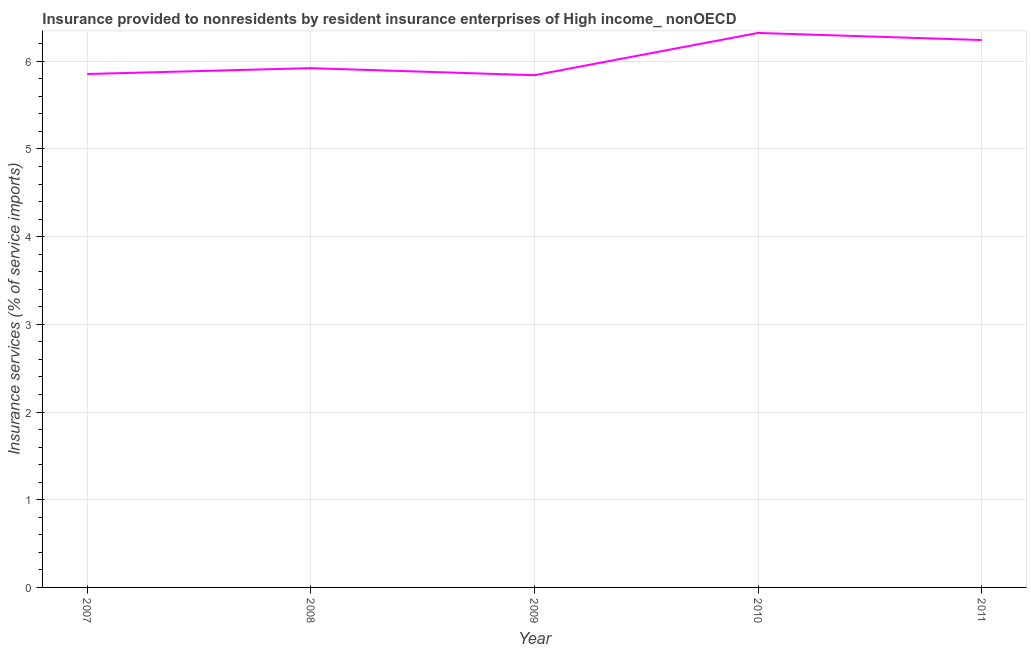What is the insurance and financial services in 2007?
Give a very brief answer. 5.86. Across all years, what is the maximum insurance and financial services?
Ensure brevity in your answer.  6.32. Across all years, what is the minimum insurance and financial services?
Offer a terse response. 5.84. What is the sum of the insurance and financial services?
Your answer should be compact. 30.18. What is the difference between the insurance and financial services in 2008 and 2009?
Give a very brief answer. 0.08. What is the average insurance and financial services per year?
Provide a succinct answer. 6.04. What is the median insurance and financial services?
Your response must be concise. 5.92. What is the ratio of the insurance and financial services in 2008 to that in 2009?
Keep it short and to the point. 1.01. What is the difference between the highest and the second highest insurance and financial services?
Provide a short and direct response. 0.08. What is the difference between the highest and the lowest insurance and financial services?
Your response must be concise. 0.48. Does the insurance and financial services monotonically increase over the years?
Provide a succinct answer. No. How many years are there in the graph?
Your answer should be very brief. 5. What is the difference between two consecutive major ticks on the Y-axis?
Give a very brief answer. 1. What is the title of the graph?
Ensure brevity in your answer.  Insurance provided to nonresidents by resident insurance enterprises of High income_ nonOECD. What is the label or title of the X-axis?
Offer a very short reply. Year. What is the label or title of the Y-axis?
Your answer should be compact. Insurance services (% of service imports). What is the Insurance services (% of service imports) of 2007?
Your answer should be very brief. 5.86. What is the Insurance services (% of service imports) of 2008?
Provide a short and direct response. 5.92. What is the Insurance services (% of service imports) of 2009?
Keep it short and to the point. 5.84. What is the Insurance services (% of service imports) of 2010?
Your response must be concise. 6.32. What is the Insurance services (% of service imports) of 2011?
Offer a terse response. 6.24. What is the difference between the Insurance services (% of service imports) in 2007 and 2008?
Offer a terse response. -0.07. What is the difference between the Insurance services (% of service imports) in 2007 and 2009?
Offer a very short reply. 0.01. What is the difference between the Insurance services (% of service imports) in 2007 and 2010?
Make the answer very short. -0.47. What is the difference between the Insurance services (% of service imports) in 2007 and 2011?
Give a very brief answer. -0.39. What is the difference between the Insurance services (% of service imports) in 2008 and 2009?
Offer a terse response. 0.08. What is the difference between the Insurance services (% of service imports) in 2008 and 2010?
Ensure brevity in your answer.  -0.4. What is the difference between the Insurance services (% of service imports) in 2008 and 2011?
Offer a terse response. -0.32. What is the difference between the Insurance services (% of service imports) in 2009 and 2010?
Keep it short and to the point. -0.48. What is the difference between the Insurance services (% of service imports) in 2009 and 2011?
Offer a terse response. -0.4. What is the difference between the Insurance services (% of service imports) in 2010 and 2011?
Offer a terse response. 0.08. What is the ratio of the Insurance services (% of service imports) in 2007 to that in 2009?
Ensure brevity in your answer.  1. What is the ratio of the Insurance services (% of service imports) in 2007 to that in 2010?
Provide a short and direct response. 0.93. What is the ratio of the Insurance services (% of service imports) in 2007 to that in 2011?
Provide a succinct answer. 0.94. What is the ratio of the Insurance services (% of service imports) in 2008 to that in 2010?
Make the answer very short. 0.94. What is the ratio of the Insurance services (% of service imports) in 2008 to that in 2011?
Keep it short and to the point. 0.95. What is the ratio of the Insurance services (% of service imports) in 2009 to that in 2010?
Your answer should be very brief. 0.92. What is the ratio of the Insurance services (% of service imports) in 2009 to that in 2011?
Offer a terse response. 0.94. 